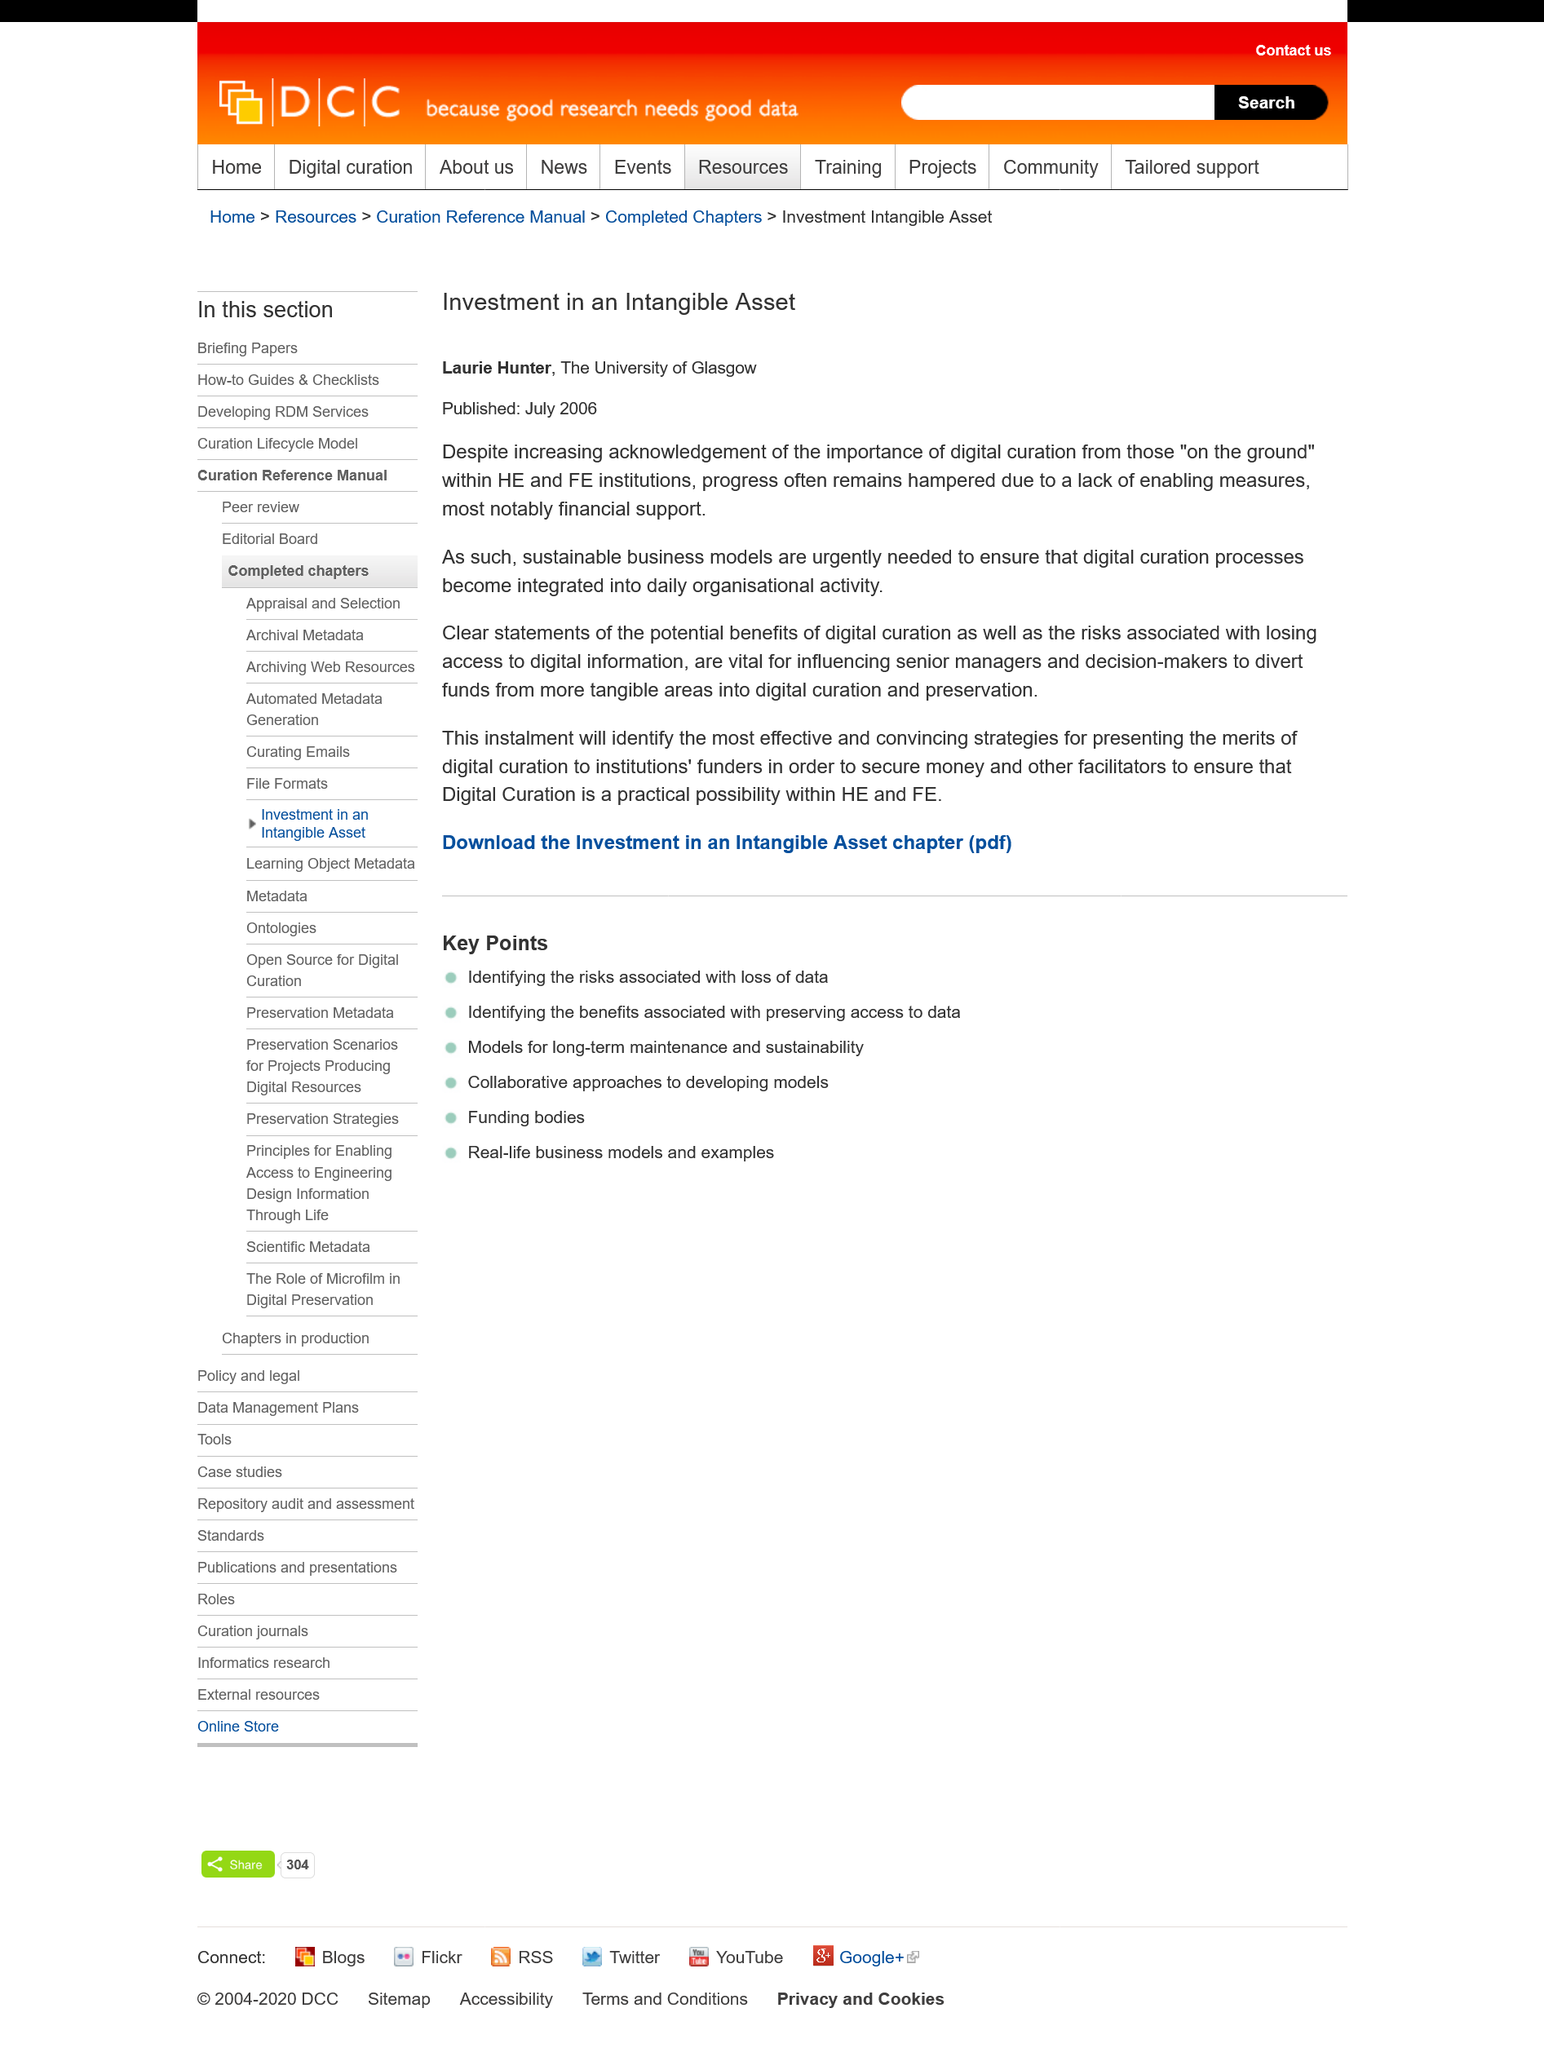Highlight a few significant elements in this photo. Laurie Hunter attends the University of Glasgow, where she previously studied. This publication was released in July 2006. This project involves investing in an intangible asset, and the name of this project is unknown. 